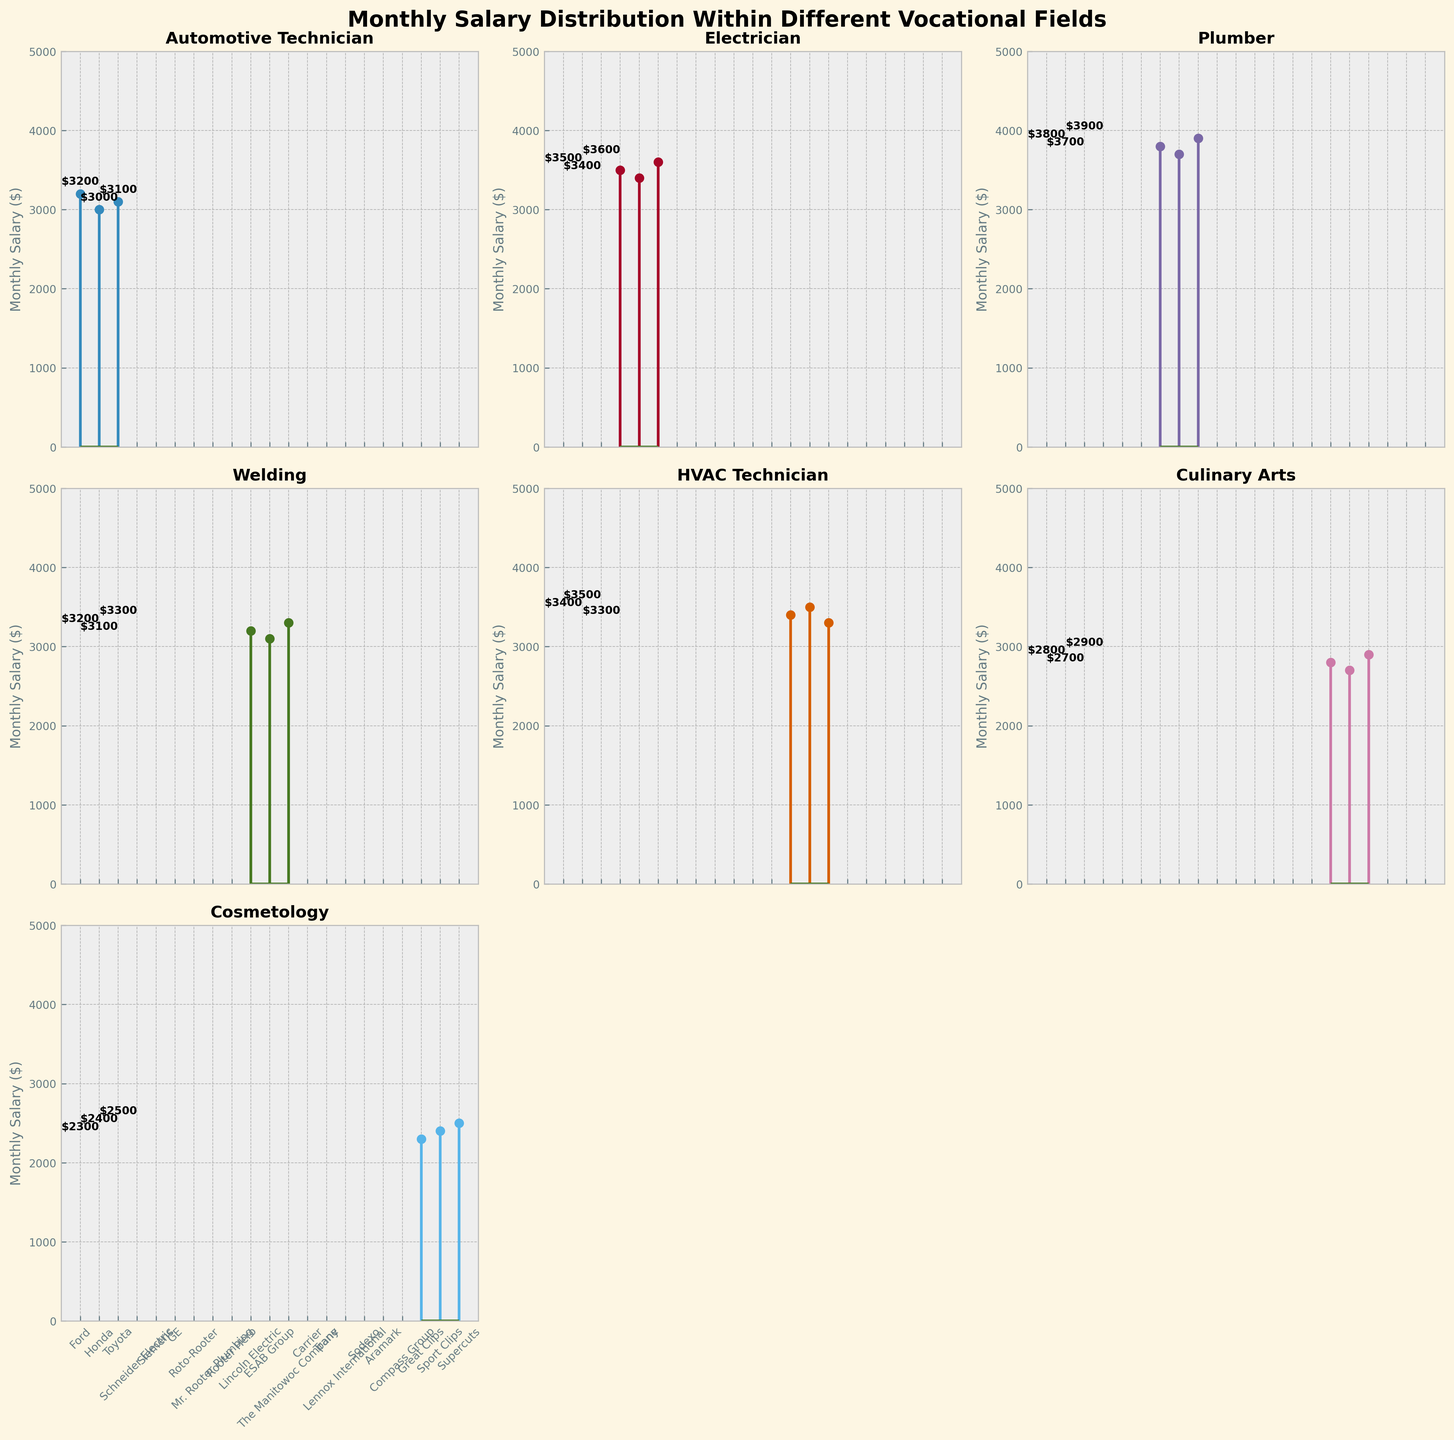What is the highest monthly salary for an Electrician? By looking at the subplot for the Electrician field, the companies and corresponding salaries are listed. The highest monthly salary can be identified by comparing the salaries visualized.
Answer: $3600 How many vocational fields are represented in the figure? Count the number of subplots; each subplot represents a separate vocational field.
Answer: 7 What's the average monthly salary for a Plumbing technician? Look at the subplot for Plumbing. The salaries are $3800, $3700, and $3900. Sum these and divide by the number of salaries. (3800 + 3700 + 3900) / 3 = 3800
Answer: $3800 Which field has a lower highest salary, Welding or Culinary Arts? Compare the highest salaries from the Welding and Culinary Arts subplots. Welding's highest salary is $3300, while Culinary Arts' highest salary is $2900.
Answer: Culinary Arts How does the highest salary in HVAC Technician compare to the highest salary in Cosmetology? Check the subplots for both HVAC Technician and Cosmetology. The highest salary in HVAC Technician is $3500, whereas for Cosmetology it is $2500.
Answer: Higher in HVAC Technician What is the median monthly salary for the Cosmetology field? For Cosmetology, the salaries are $2300, $2400, and $2500. The median is the middle value when sorted in ascending order.
Answer: $2400 Which field offers the lowest salary among the represented fields? By examining the figure, look for the subplot with the lowest salary value among all fields. Cosmetology has the lowest salary at $2300.
Answer: Cosmetology What is the difference between the highest and lowest monthly salaries for an Automotive Technician? Find the highest and lowest salaries for Automotive Technician, which are $3200 and $3000. Subtract the lowest from the highest. $3200 - $3000 = $200
Answer: $200 How many companies are listed under the Electrician field? Count the number of companies in the Electrician subplot.
Answer: 3 What is the range of monthly salaries for a Culinary Arts professional? Find the difference between the highest salary ($2900) and the lowest salary ($2700) in the Culinary Arts subplot. $2900 - $2700 = $200
Answer: $200 